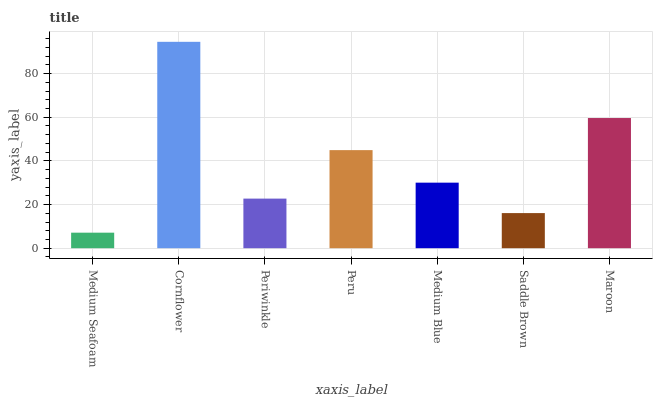Is Medium Seafoam the minimum?
Answer yes or no. Yes. Is Cornflower the maximum?
Answer yes or no. Yes. Is Periwinkle the minimum?
Answer yes or no. No. Is Periwinkle the maximum?
Answer yes or no. No. Is Cornflower greater than Periwinkle?
Answer yes or no. Yes. Is Periwinkle less than Cornflower?
Answer yes or no. Yes. Is Periwinkle greater than Cornflower?
Answer yes or no. No. Is Cornflower less than Periwinkle?
Answer yes or no. No. Is Medium Blue the high median?
Answer yes or no. Yes. Is Medium Blue the low median?
Answer yes or no. Yes. Is Medium Seafoam the high median?
Answer yes or no. No. Is Medium Seafoam the low median?
Answer yes or no. No. 